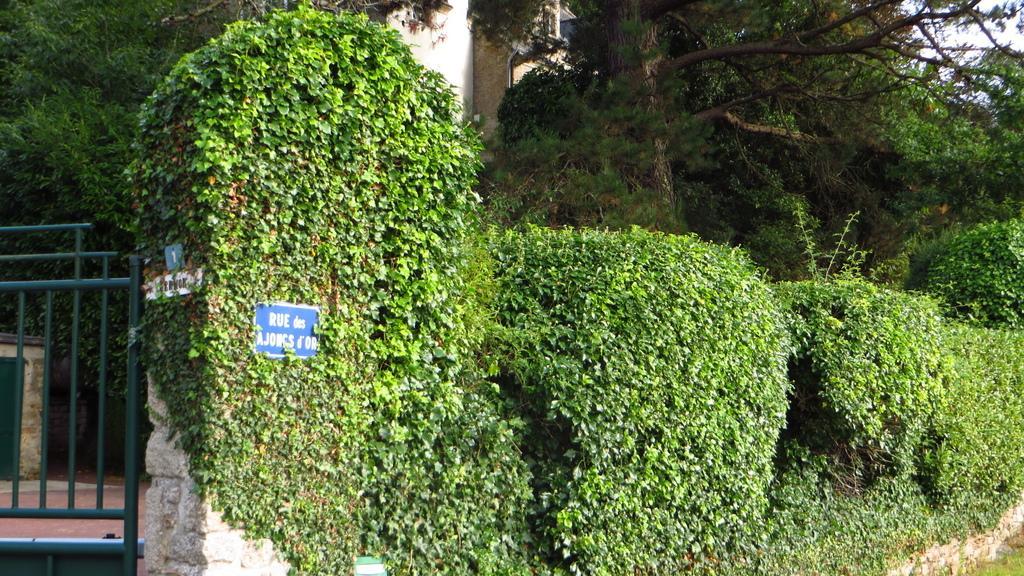In one or two sentences, can you explain what this image depicts? In this image I can see trees in green color, at left I can see a blue color board attached to the wall and gate is also in green color. At the back I can see building in cream color and sky in white color. 